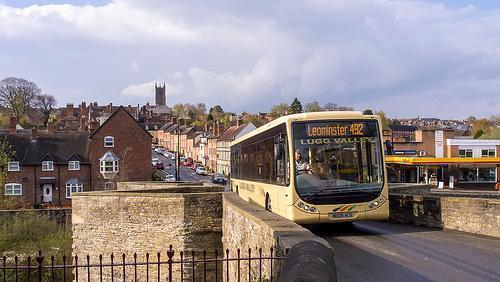How many buses are on the bridge?
Give a very brief answer. 1. 